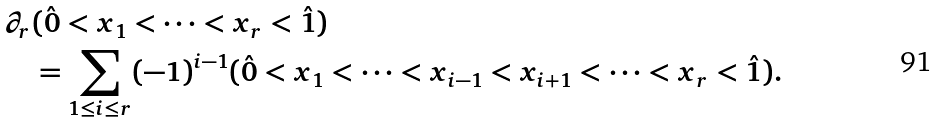<formula> <loc_0><loc_0><loc_500><loc_500>\partial _ { r } & ( \hat { 0 } < x _ { 1 } < \dots < x _ { r } < \hat { 1 } ) \\ & = \sum _ { 1 \leq i \leq r } ( - 1 ) ^ { i - 1 } ( \hat { 0 } < x _ { 1 } < \cdots < x _ { i - 1 } < x _ { i + 1 } < \cdots < x _ { r } < \hat { 1 } ) .</formula> 